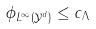<formula> <loc_0><loc_0><loc_500><loc_500>\| \phi \| _ { L ^ { \infty } ( \mathcal { Y } ^ { d } ) } \leq c _ { \Lambda }</formula> 